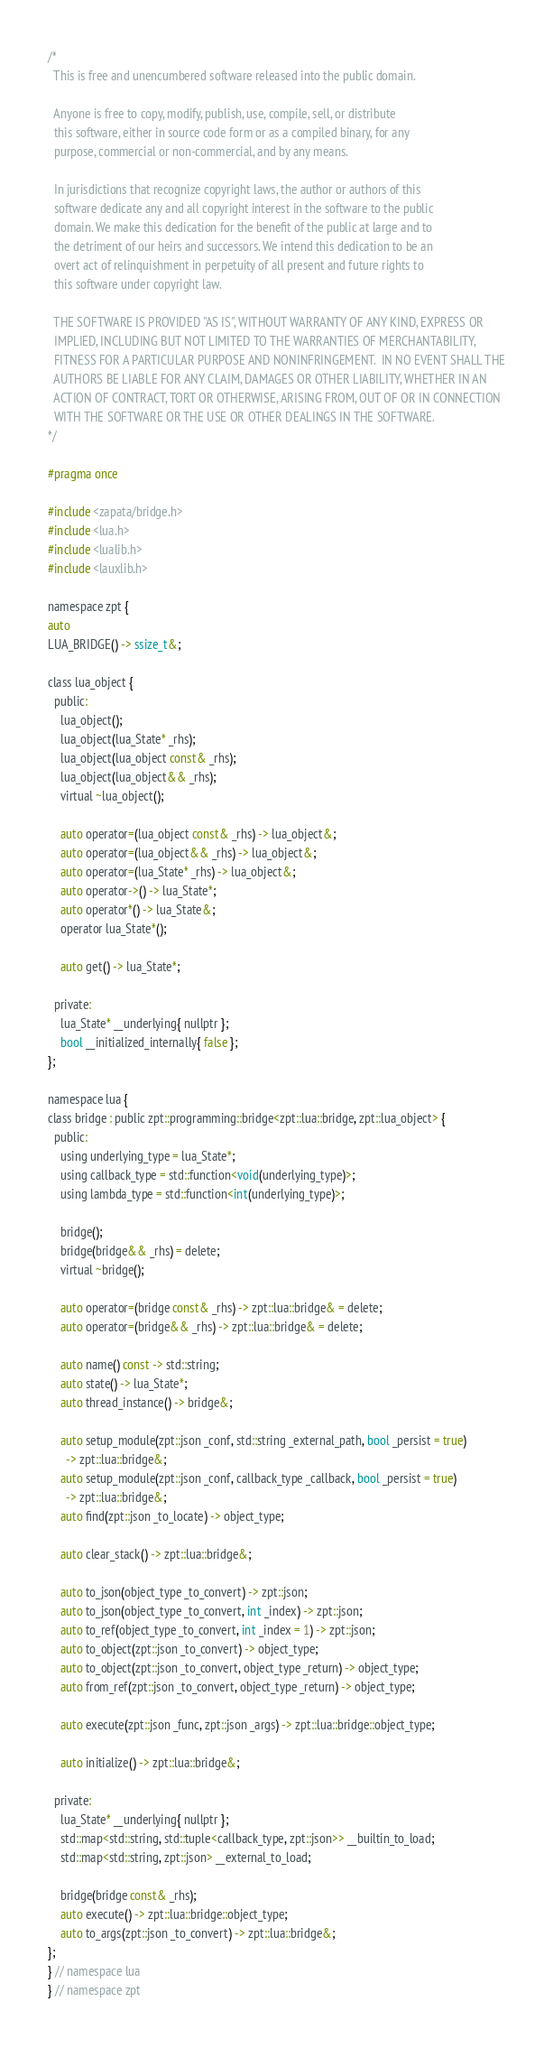Convert code to text. <code><loc_0><loc_0><loc_500><loc_500><_C_>/*
  This is free and unencumbered software released into the public domain.

  Anyone is free to copy, modify, publish, use, compile, sell, or distribute
  this software, either in source code form or as a compiled binary, for any
  purpose, commercial or non-commercial, and by any means.

  In jurisdictions that recognize copyright laws, the author or authors of this
  software dedicate any and all copyright interest in the software to the public
  domain. We make this dedication for the benefit of the public at large and to
  the detriment of our heirs and successors. We intend this dedication to be an
  overt act of relinquishment in perpetuity of all present and future rights to
  this software under copyright law.

  THE SOFTWARE IS PROVIDED "AS IS", WITHOUT WARRANTY OF ANY KIND, EXPRESS OR
  IMPLIED, INCLUDING BUT NOT LIMITED TO THE WARRANTIES OF MERCHANTABILITY,
  FITNESS FOR A PARTICULAR PURPOSE AND NONINFRINGEMENT.  IN NO EVENT SHALL THE
  AUTHORS BE LIABLE FOR ANY CLAIM, DAMAGES OR OTHER LIABILITY, WHETHER IN AN
  ACTION OF CONTRACT, TORT OR OTHERWISE, ARISING FROM, OUT OF OR IN CONNECTION
  WITH THE SOFTWARE OR THE USE OR OTHER DEALINGS IN THE SOFTWARE.
*/

#pragma once

#include <zapata/bridge.h>
#include <lua.h>
#include <lualib.h>
#include <lauxlib.h>

namespace zpt {
auto
LUA_BRIDGE() -> ssize_t&;

class lua_object {
  public:
    lua_object();
    lua_object(lua_State* _rhs);
    lua_object(lua_object const& _rhs);
    lua_object(lua_object&& _rhs);
    virtual ~lua_object();

    auto operator=(lua_object const& _rhs) -> lua_object&;
    auto operator=(lua_object&& _rhs) -> lua_object&;
    auto operator=(lua_State* _rhs) -> lua_object&;
    auto operator->() -> lua_State*;
    auto operator*() -> lua_State&;
    operator lua_State*();

    auto get() -> lua_State*;

  private:
    lua_State* __underlying{ nullptr };
    bool __initialized_internally{ false };
};

namespace lua {
class bridge : public zpt::programming::bridge<zpt::lua::bridge, zpt::lua_object> {
  public:
    using underlying_type = lua_State*;
    using callback_type = std::function<void(underlying_type)>;
    using lambda_type = std::function<int(underlying_type)>;

    bridge();
    bridge(bridge&& _rhs) = delete;
    virtual ~bridge();

    auto operator=(bridge const& _rhs) -> zpt::lua::bridge& = delete;
    auto operator=(bridge&& _rhs) -> zpt::lua::bridge& = delete;

    auto name() const -> std::string;
    auto state() -> lua_State*;
    auto thread_instance() -> bridge&;

    auto setup_module(zpt::json _conf, std::string _external_path, bool _persist = true)
      -> zpt::lua::bridge&;
    auto setup_module(zpt::json _conf, callback_type _callback, bool _persist = true)
      -> zpt::lua::bridge&;
    auto find(zpt::json _to_locate) -> object_type;

    auto clear_stack() -> zpt::lua::bridge&;

    auto to_json(object_type _to_convert) -> zpt::json;
    auto to_json(object_type _to_convert, int _index) -> zpt::json;
    auto to_ref(object_type _to_convert, int _index = 1) -> zpt::json;
    auto to_object(zpt::json _to_convert) -> object_type;
    auto to_object(zpt::json _to_convert, object_type _return) -> object_type;
    auto from_ref(zpt::json _to_convert, object_type _return) -> object_type;

    auto execute(zpt::json _func, zpt::json _args) -> zpt::lua::bridge::object_type;

    auto initialize() -> zpt::lua::bridge&;

  private:
    lua_State* __underlying{ nullptr };
    std::map<std::string, std::tuple<callback_type, zpt::json>> __builtin_to_load;
    std::map<std::string, zpt::json> __external_to_load;

    bridge(bridge const& _rhs);
    auto execute() -> zpt::lua::bridge::object_type;
    auto to_args(zpt::json _to_convert) -> zpt::lua::bridge&;
};
} // namespace lua
} // namespace zpt
</code> 